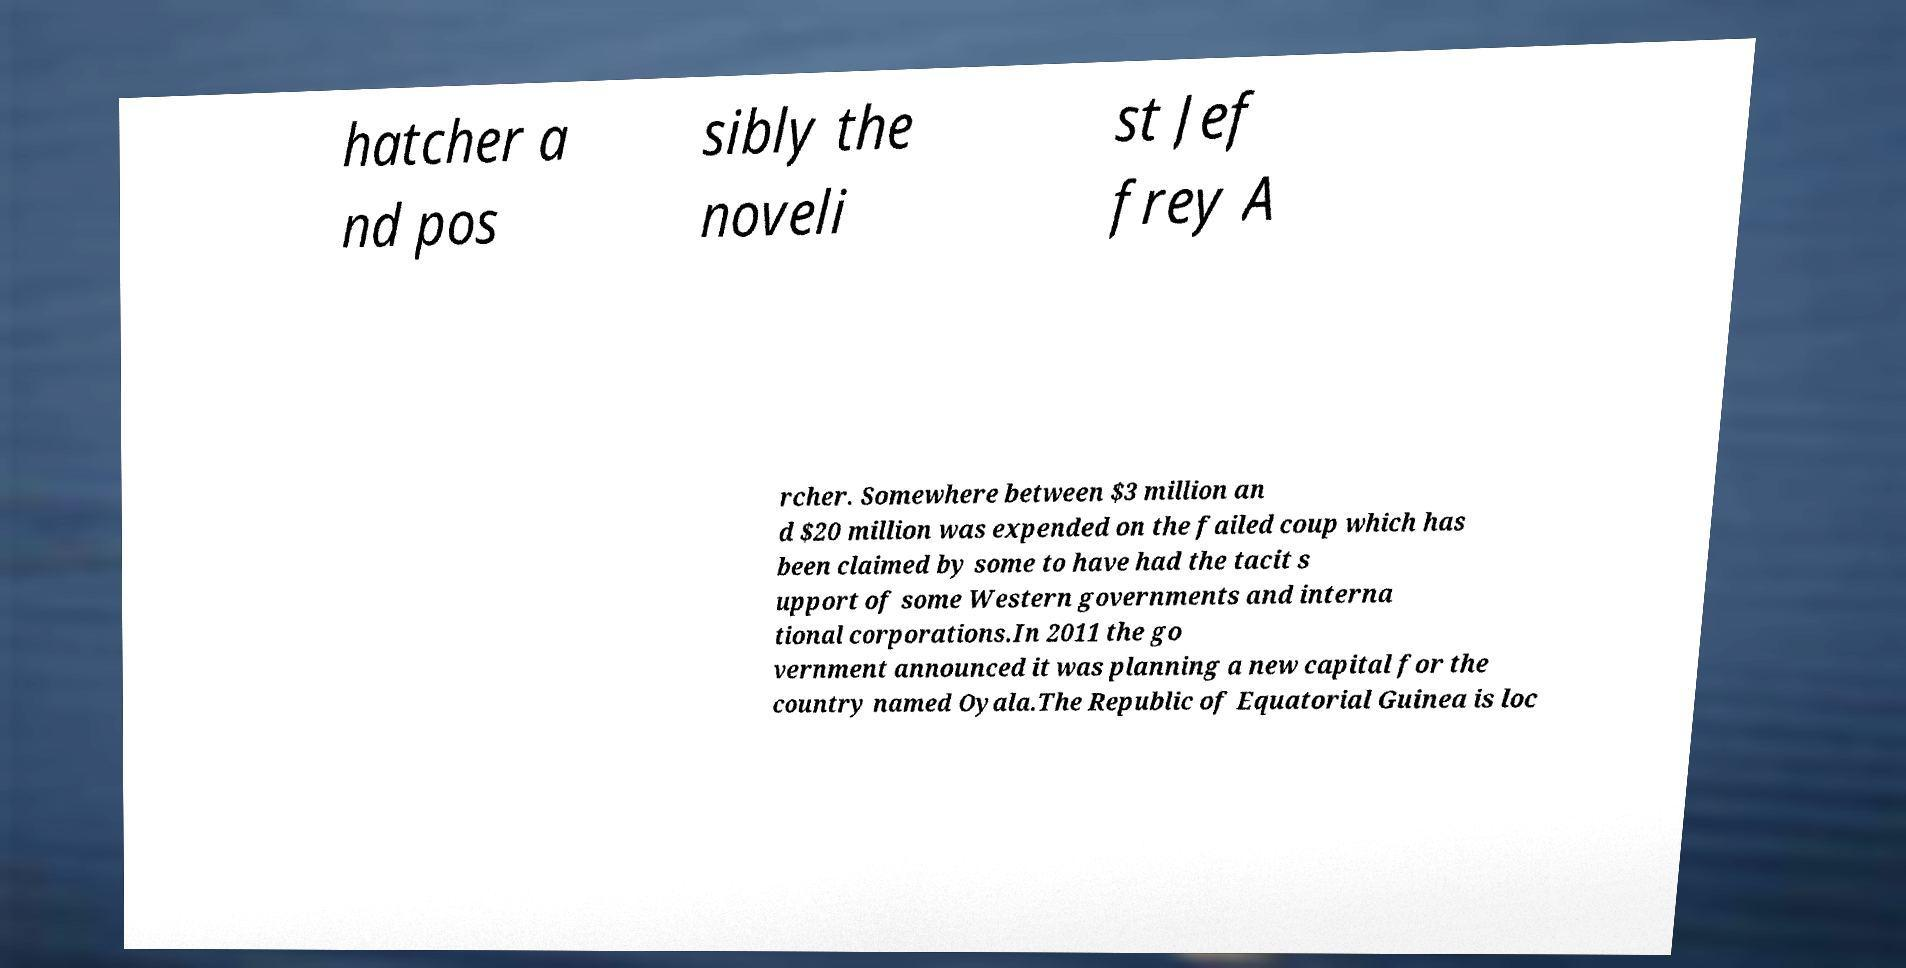Please identify and transcribe the text found in this image. hatcher a nd pos sibly the noveli st Jef frey A rcher. Somewhere between $3 million an d $20 million was expended on the failed coup which has been claimed by some to have had the tacit s upport of some Western governments and interna tional corporations.In 2011 the go vernment announced it was planning a new capital for the country named Oyala.The Republic of Equatorial Guinea is loc 